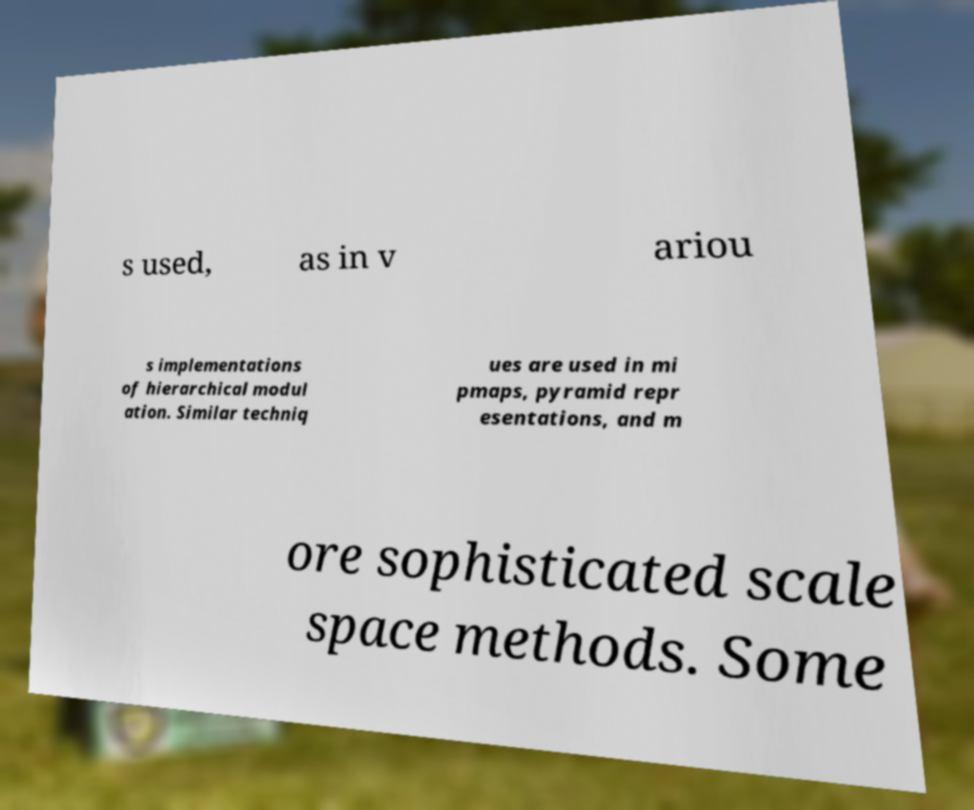Could you extract and type out the text from this image? s used, as in v ariou s implementations of hierarchical modul ation. Similar techniq ues are used in mi pmaps, pyramid repr esentations, and m ore sophisticated scale space methods. Some 